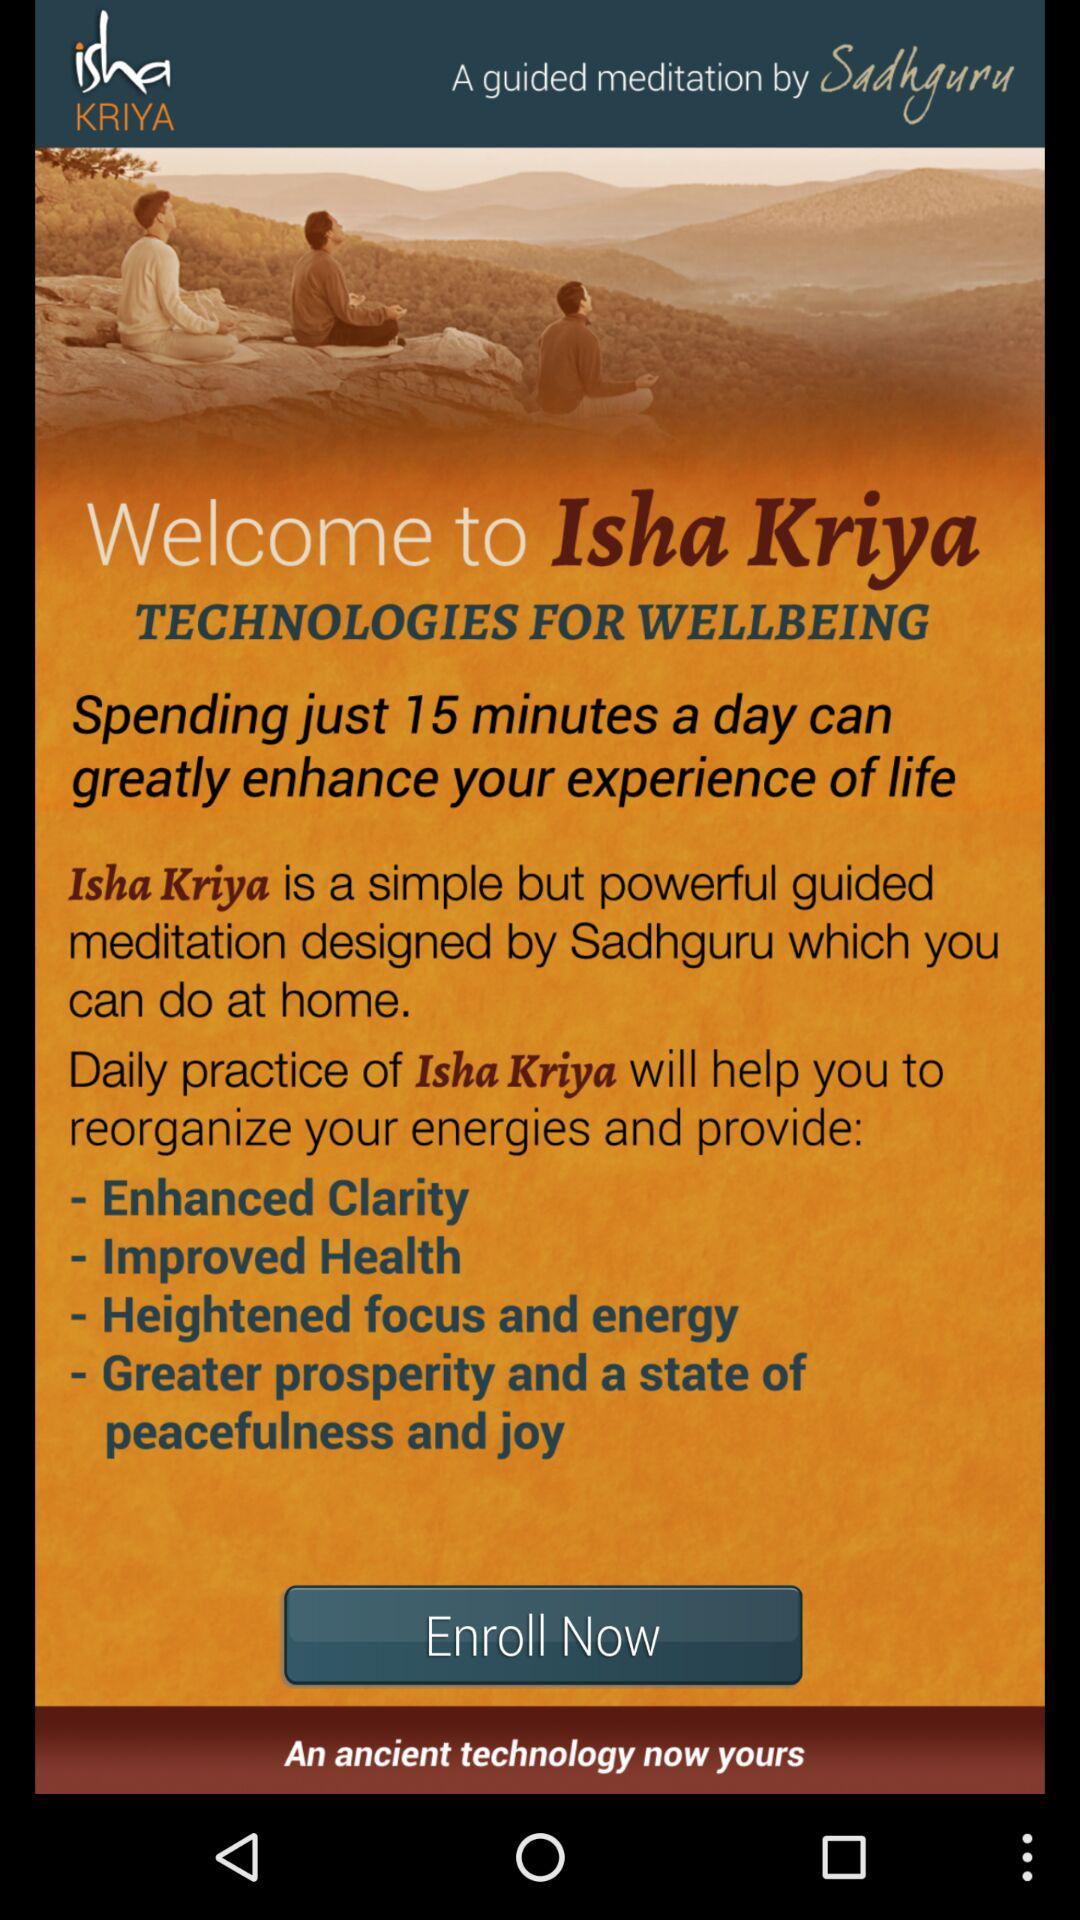How old is the practice of "Isha Kriya"?
When the provided information is insufficient, respond with <no answer>. <no answer> 